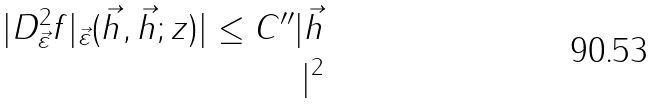<formula> <loc_0><loc_0><loc_500><loc_500>| D ^ { 2 } _ { \vec { \varepsilon } } f | _ { \vec { \varepsilon } } ( \vec { h } , \vec { h } ; z ) | \leq C ^ { \prime \prime } | \vec { h } \\ | ^ { 2 }</formula> 